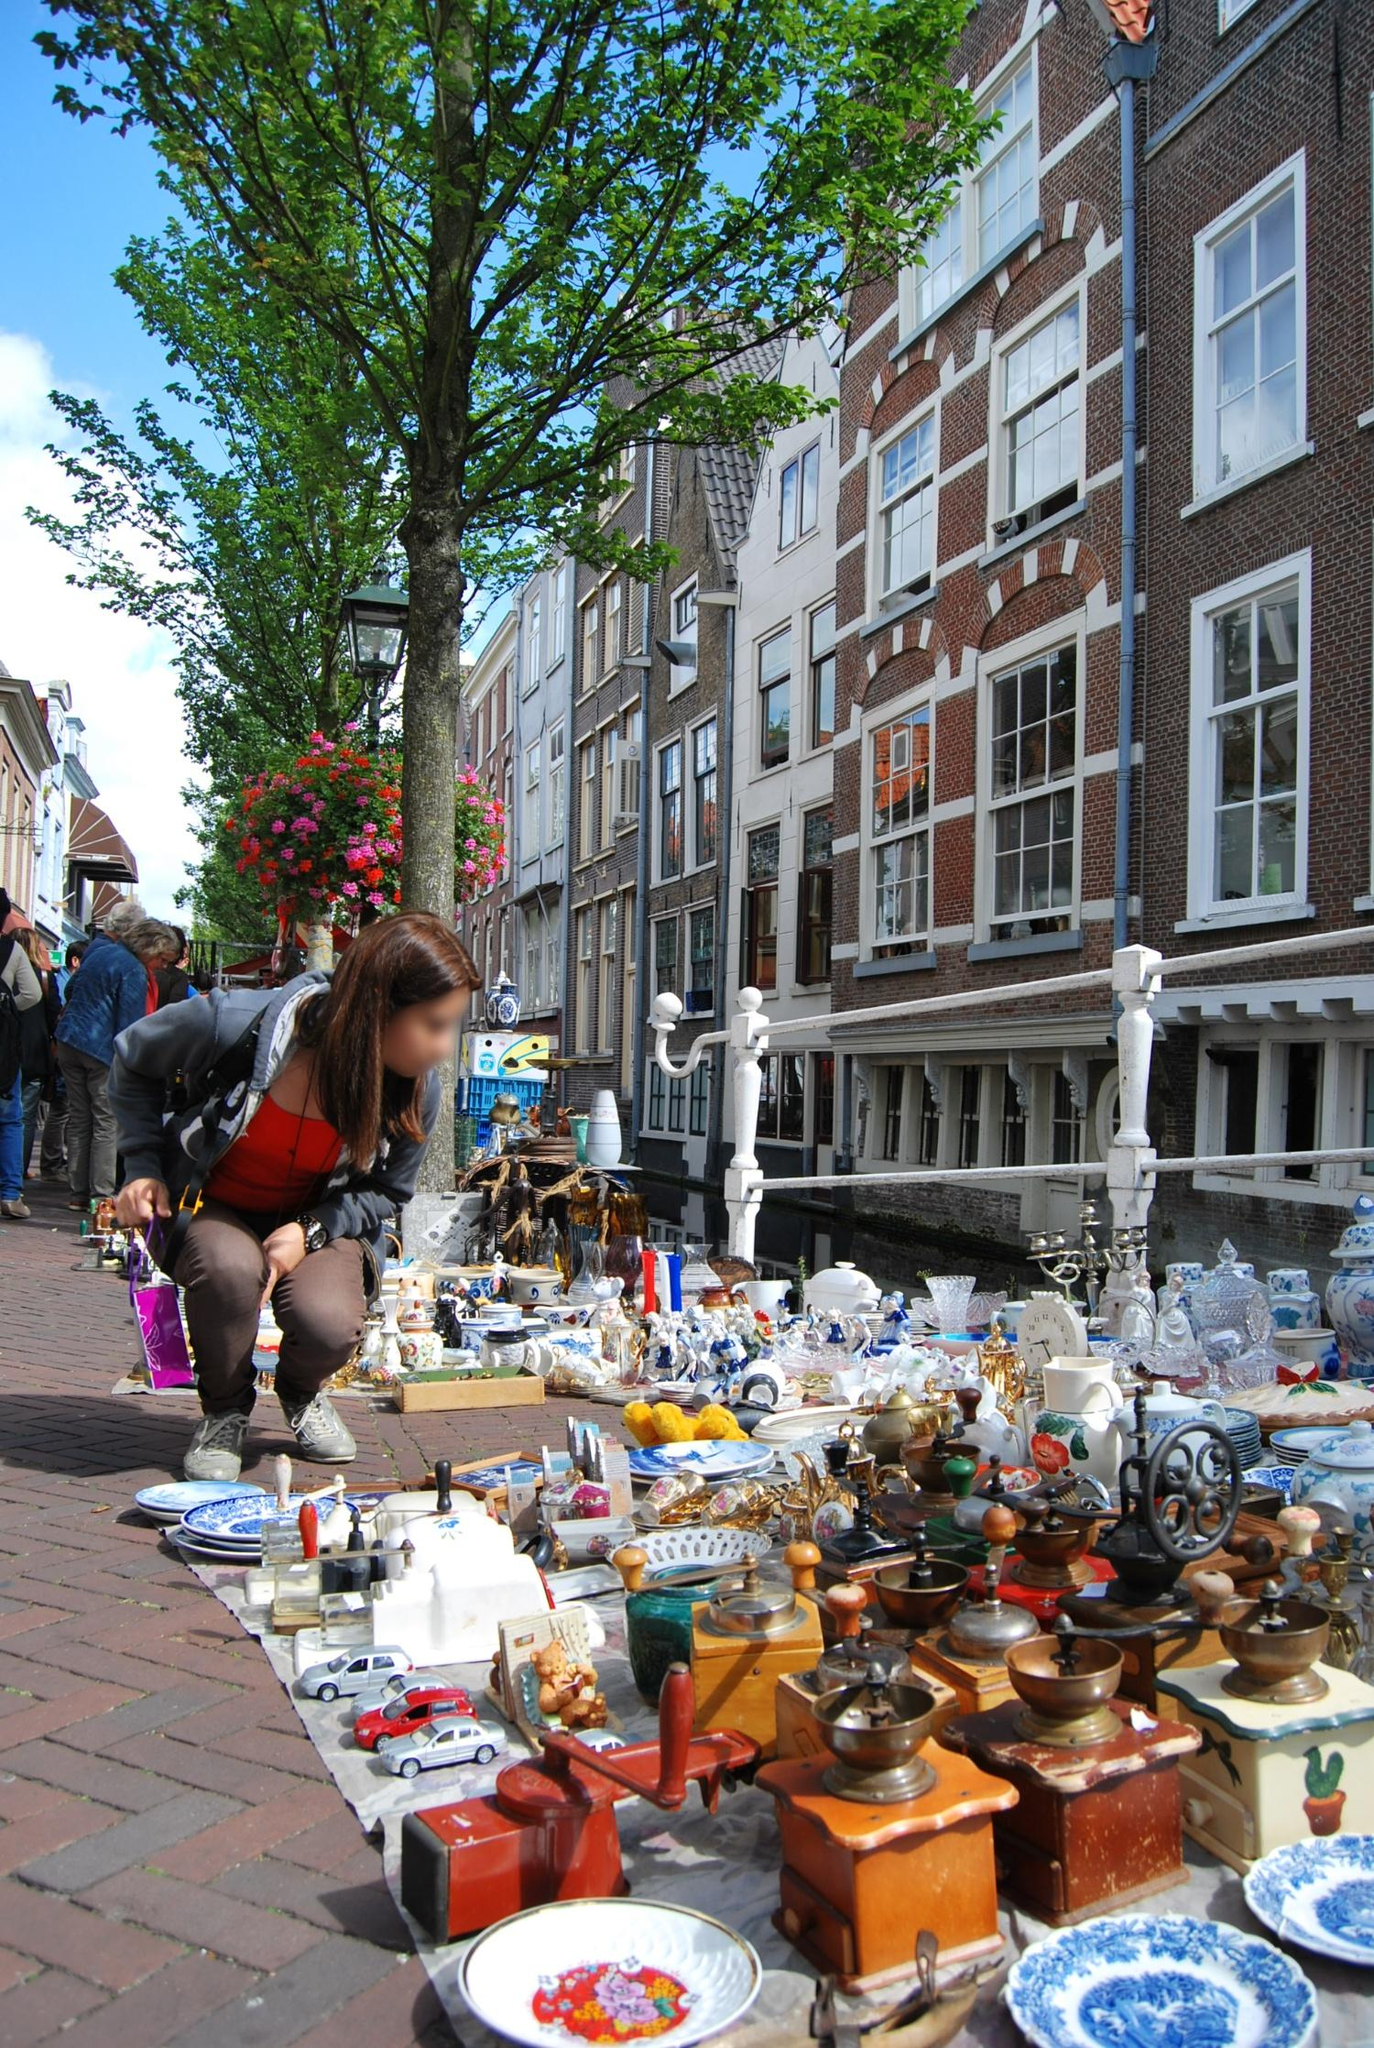Can you describe the main features of this image for me? The image showcases a bustling street market in Amsterdam, Netherlands. There are several market stalls filled with various colorful trinkets, antiques, and decorative items. The sellers have neatly laid out an extensive collection of items including miniature toy cars, porcelain plates, old-fashioned coffee grinders, and ornate figurines. People are actively browsing through the items, adding a sense of liveliness to the scene.

In the background, you can see typical Amsterdam architecture characterized by narrow brick facades and large, multi-paned windows. The buildings have a historic charm, standing tall and close together along the street. The sky is a serene blue with a few scattered clouds, enhancing the overall pleasant atmosphere. Trees line the street, their green leaves complementing the scene with a touch of nature. A lamp post adorned with hanging flower baskets adds to the picturesque setting. 